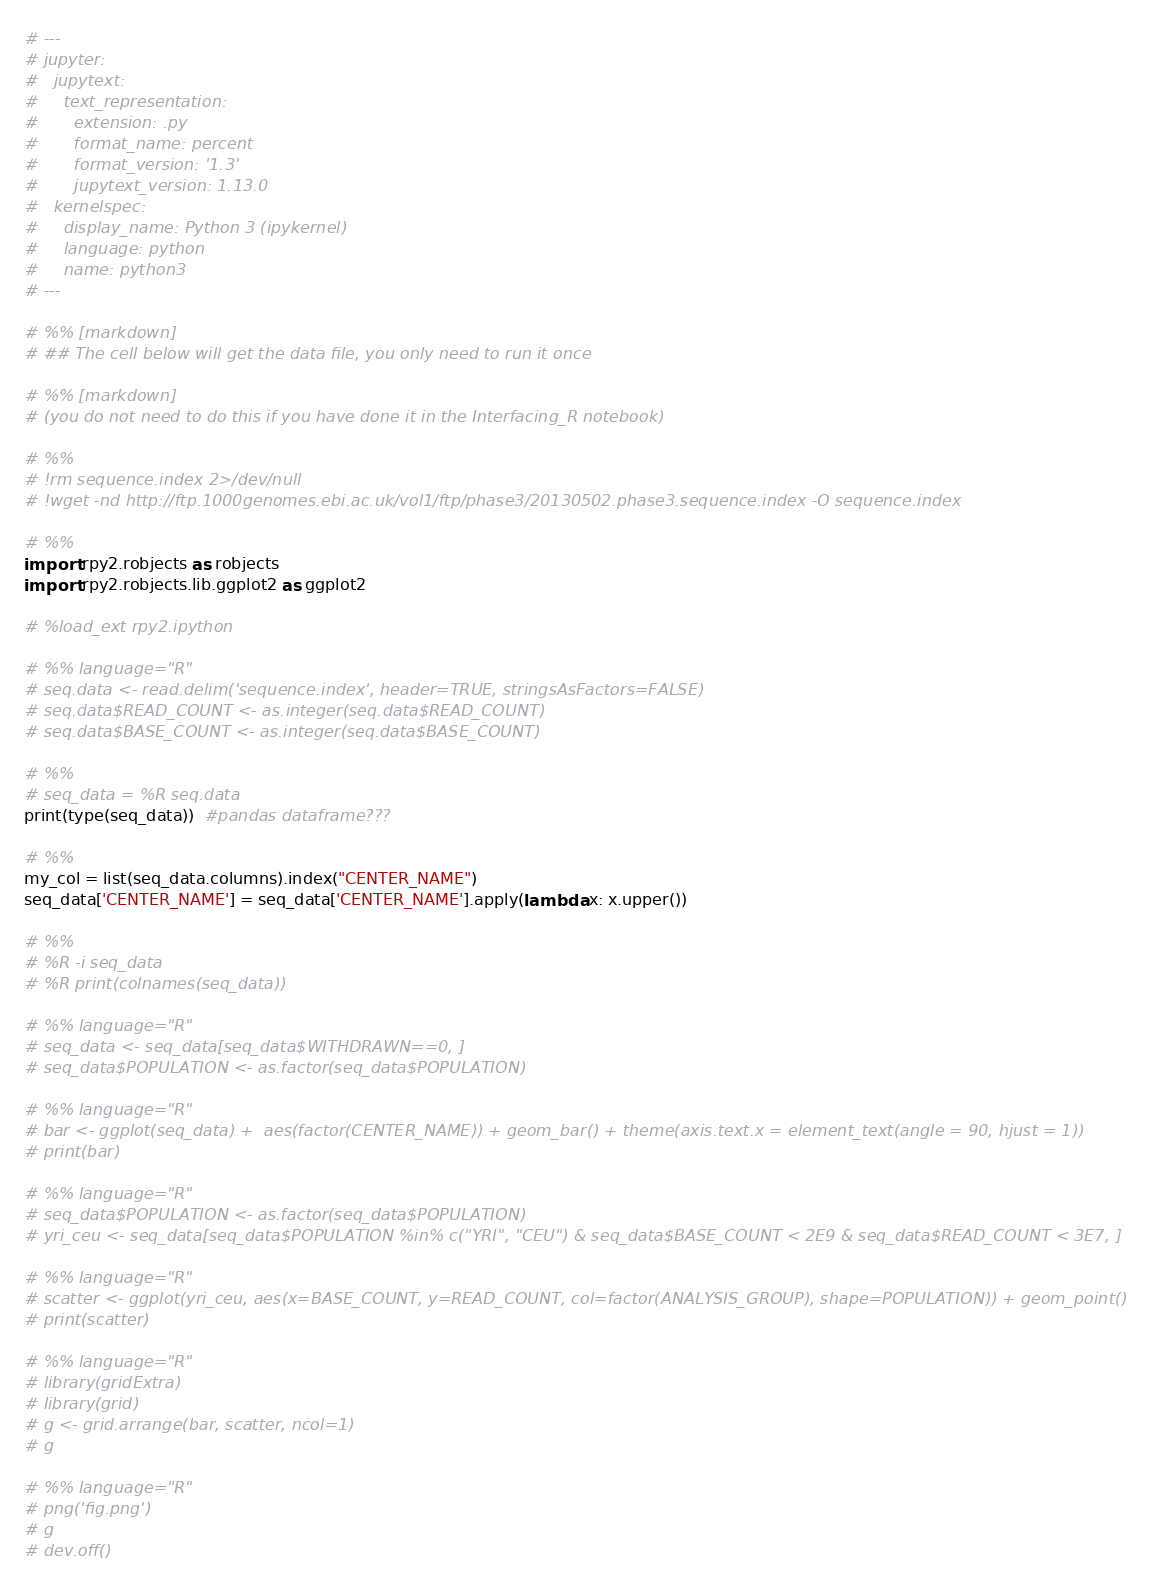<code> <loc_0><loc_0><loc_500><loc_500><_Python_># ---
# jupyter:
#   jupytext:
#     text_representation:
#       extension: .py
#       format_name: percent
#       format_version: '1.3'
#       jupytext_version: 1.13.0
#   kernelspec:
#     display_name: Python 3 (ipykernel)
#     language: python
#     name: python3
# ---

# %% [markdown]
# ## The cell below will get the data file, you only need to run it once 

# %% [markdown]
# (you do not need to do this if you have done it in the Interfacing_R notebook)

# %%
# !rm sequence.index 2>/dev/null
# !wget -nd http://ftp.1000genomes.ebi.ac.uk/vol1/ftp/phase3/20130502.phase3.sequence.index -O sequence.index

# %%
import rpy2.robjects as robjects
import rpy2.robjects.lib.ggplot2 as ggplot2

# %load_ext rpy2.ipython

# %% language="R"
# seq.data <- read.delim('sequence.index', header=TRUE, stringsAsFactors=FALSE)
# seq.data$READ_COUNT <- as.integer(seq.data$READ_COUNT)
# seq.data$BASE_COUNT <- as.integer(seq.data$BASE_COUNT)

# %%
# seq_data = %R seq.data
print(type(seq_data))  #pandas dataframe???

# %%
my_col = list(seq_data.columns).index("CENTER_NAME")
seq_data['CENTER_NAME'] = seq_data['CENTER_NAME'].apply(lambda x: x.upper())

# %%
# %R -i seq_data
# %R print(colnames(seq_data))

# %% language="R"
# seq_data <- seq_data[seq_data$WITHDRAWN==0, ]
# seq_data$POPULATION <- as.factor(seq_data$POPULATION)

# %% language="R"
# bar <- ggplot(seq_data) +  aes(factor(CENTER_NAME)) + geom_bar() + theme(axis.text.x = element_text(angle = 90, hjust = 1))
# print(bar)

# %% language="R"
# seq_data$POPULATION <- as.factor(seq_data$POPULATION)
# yri_ceu <- seq_data[seq_data$POPULATION %in% c("YRI", "CEU") & seq_data$BASE_COUNT < 2E9 & seq_data$READ_COUNT < 3E7, ]

# %% language="R"
# scatter <- ggplot(yri_ceu, aes(x=BASE_COUNT, y=READ_COUNT, col=factor(ANALYSIS_GROUP), shape=POPULATION)) + geom_point()
# print(scatter)

# %% language="R"
# library(gridExtra)
# library(grid)
# g <- grid.arrange(bar, scatter, ncol=1)
# g

# %% language="R"
# png('fig.png')
# g
# dev.off()
</code> 